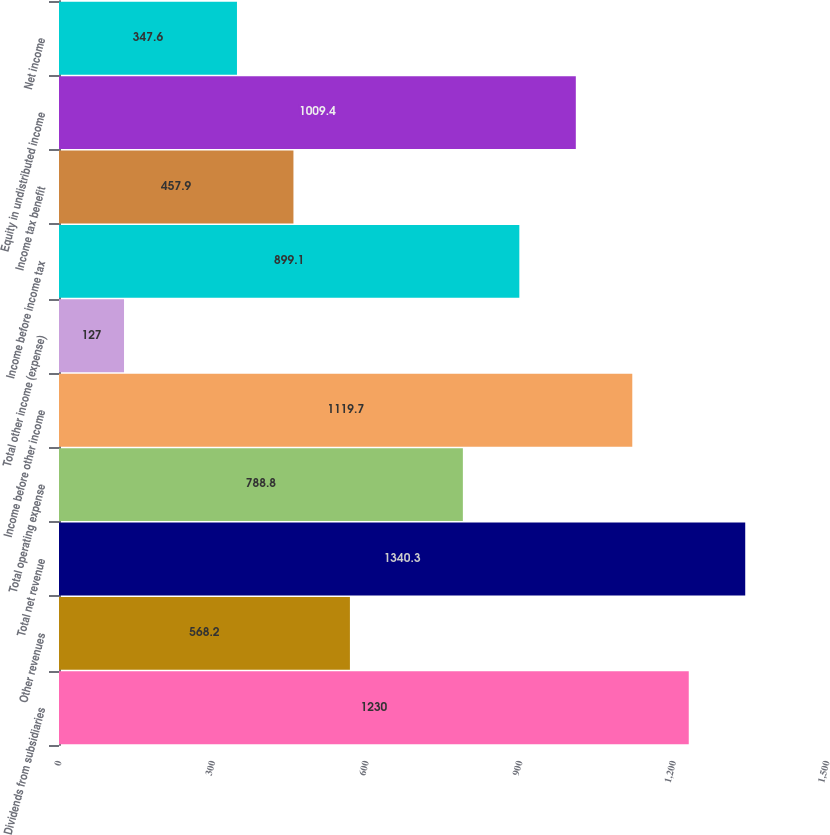<chart> <loc_0><loc_0><loc_500><loc_500><bar_chart><fcel>Dividends from subsidiaries<fcel>Other revenues<fcel>Total net revenue<fcel>Total operating expense<fcel>Income before other income<fcel>Total other income (expense)<fcel>Income before income tax<fcel>Income tax benefit<fcel>Equity in undistributed income<fcel>Net income<nl><fcel>1230<fcel>568.2<fcel>1340.3<fcel>788.8<fcel>1119.7<fcel>127<fcel>899.1<fcel>457.9<fcel>1009.4<fcel>347.6<nl></chart> 